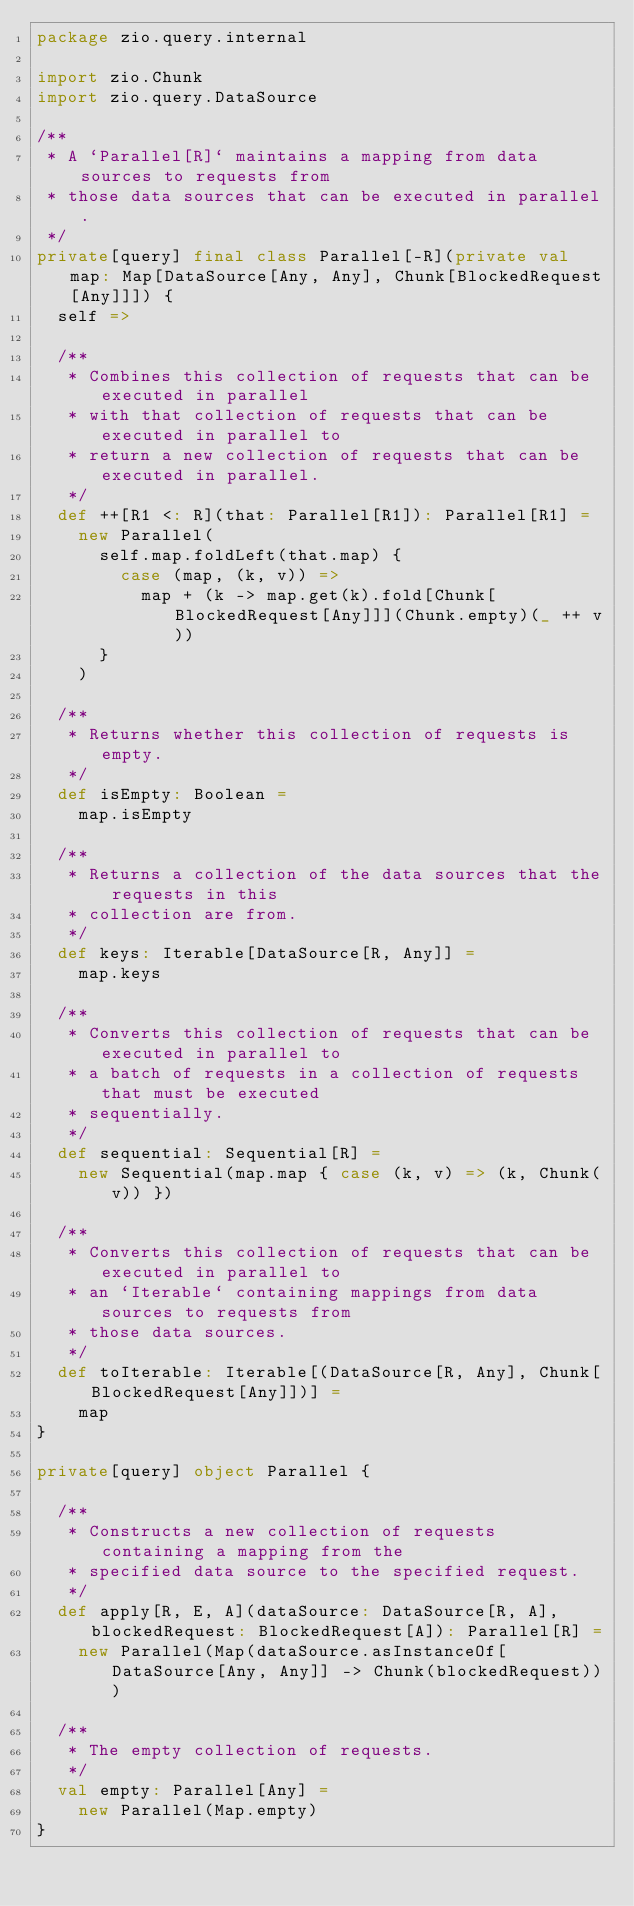<code> <loc_0><loc_0><loc_500><loc_500><_Scala_>package zio.query.internal

import zio.Chunk
import zio.query.DataSource

/**
 * A `Parallel[R]` maintains a mapping from data sources to requests from
 * those data sources that can be executed in parallel.
 */
private[query] final class Parallel[-R](private val map: Map[DataSource[Any, Any], Chunk[BlockedRequest[Any]]]) {
  self =>

  /**
   * Combines this collection of requests that can be executed in parallel
   * with that collection of requests that can be executed in parallel to
   * return a new collection of requests that can be executed in parallel.
   */
  def ++[R1 <: R](that: Parallel[R1]): Parallel[R1] =
    new Parallel(
      self.map.foldLeft(that.map) {
        case (map, (k, v)) =>
          map + (k -> map.get(k).fold[Chunk[BlockedRequest[Any]]](Chunk.empty)(_ ++ v))
      }
    )

  /**
   * Returns whether this collection of requests is empty.
   */
  def isEmpty: Boolean =
    map.isEmpty

  /**
   * Returns a collection of the data sources that the requests in this
   * collection are from.
   */
  def keys: Iterable[DataSource[R, Any]] =
    map.keys

  /**
   * Converts this collection of requests that can be executed in parallel to
   * a batch of requests in a collection of requests that must be executed
   * sequentially.
   */
  def sequential: Sequential[R] =
    new Sequential(map.map { case (k, v) => (k, Chunk(v)) })

  /**
   * Converts this collection of requests that can be executed in parallel to
   * an `Iterable` containing mappings from data sources to requests from
   * those data sources.
   */
  def toIterable: Iterable[(DataSource[R, Any], Chunk[BlockedRequest[Any]])] =
    map
}

private[query] object Parallel {

  /**
   * Constructs a new collection of requests containing a mapping from the
   * specified data source to the specified request.
   */
  def apply[R, E, A](dataSource: DataSource[R, A], blockedRequest: BlockedRequest[A]): Parallel[R] =
    new Parallel(Map(dataSource.asInstanceOf[DataSource[Any, Any]] -> Chunk(blockedRequest)))

  /**
   * The empty collection of requests.
   */
  val empty: Parallel[Any] =
    new Parallel(Map.empty)
}
</code> 